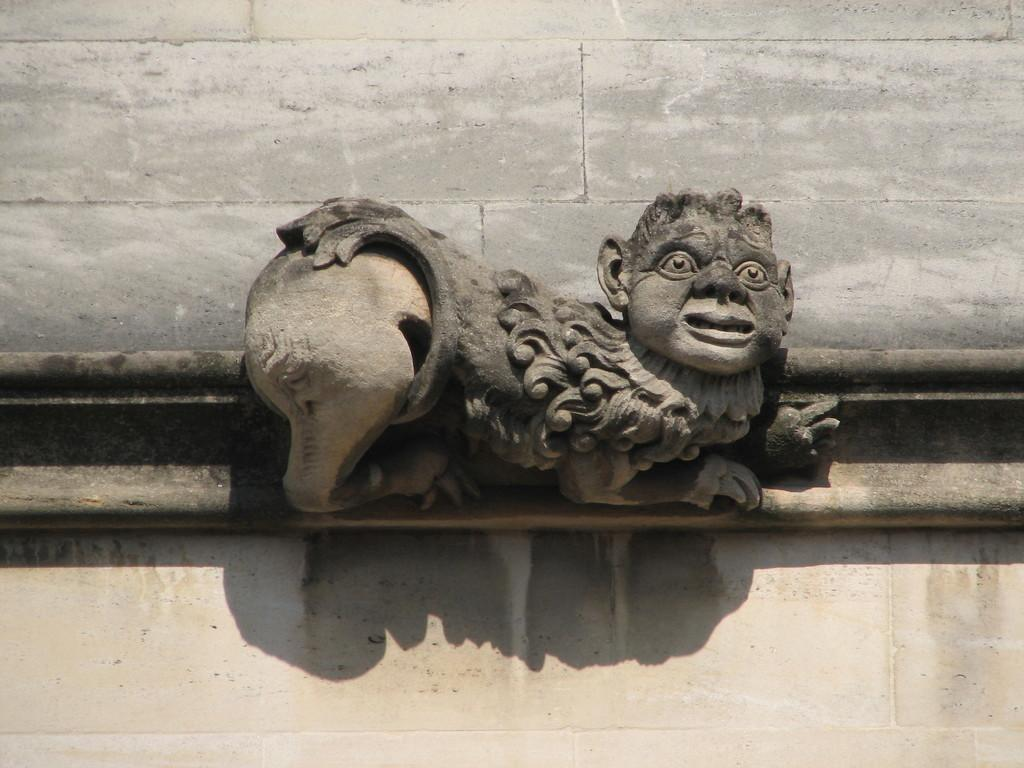What is the main subject in the center of the image? There is a sculpture in the center of the image. What type of structure is visible at the top of the image? There is a brick wall at the top of the image. What is located at the bottom of the image? There is a well at the bottom of the image. How would you describe the weather in the image? The image appears to be sunny. What type of meat is hanging from the sculpture in the image? There is no meat present in the image; it features a sculpture, a brick wall, and a well. 